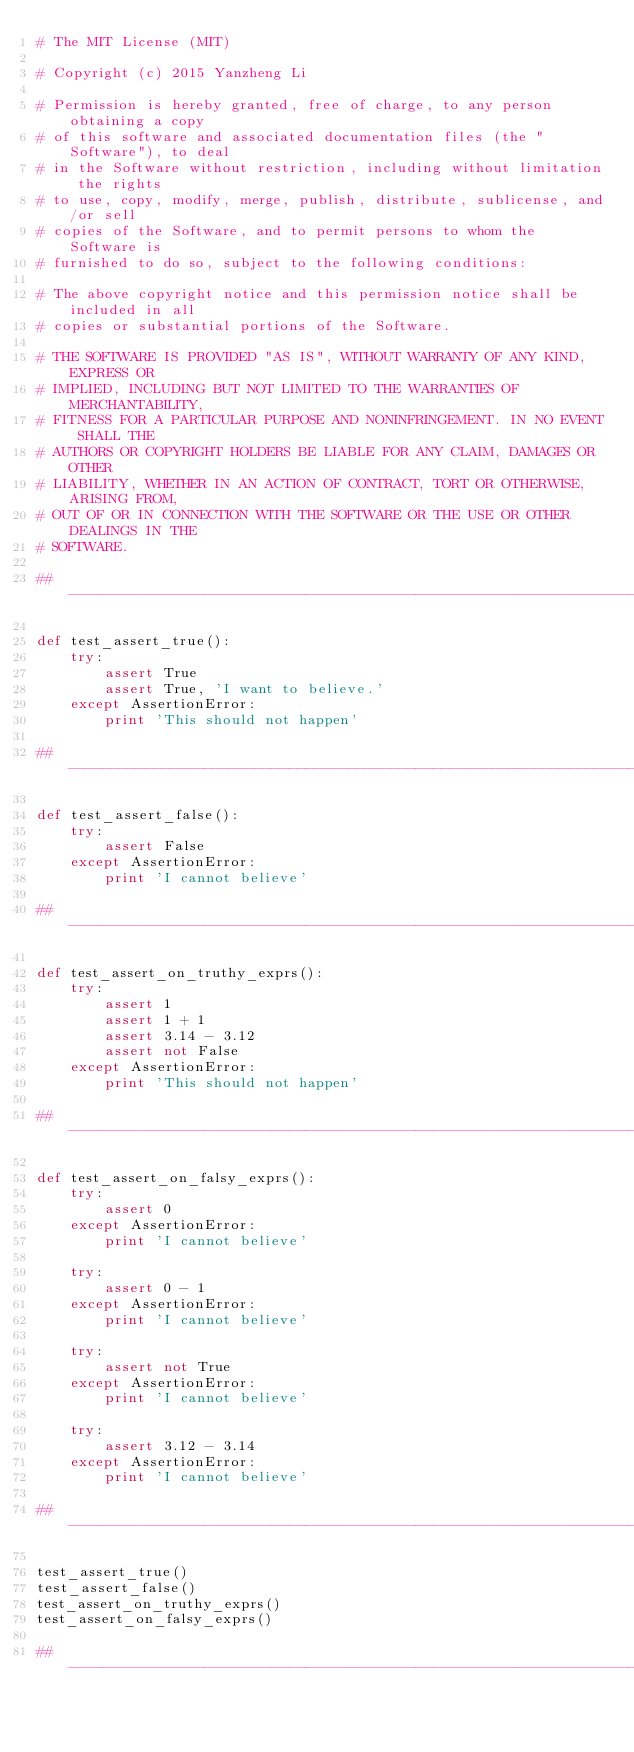Convert code to text. <code><loc_0><loc_0><loc_500><loc_500><_Python_># The MIT License (MIT)

# Copyright (c) 2015 Yanzheng Li

# Permission is hereby granted, free of charge, to any person obtaining a copy
# of this software and associated documentation files (the "Software"), to deal
# in the Software without restriction, including without limitation the rights
# to use, copy, modify, merge, publish, distribute, sublicense, and/or sell
# copies of the Software, and to permit persons to whom the Software is
# furnished to do so, subject to the following conditions:

# The above copyright notice and this permission notice shall be included in all
# copies or substantial portions of the Software.

# THE SOFTWARE IS PROVIDED "AS IS", WITHOUT WARRANTY OF ANY KIND, EXPRESS OR
# IMPLIED, INCLUDING BUT NOT LIMITED TO THE WARRANTIES OF MERCHANTABILITY,
# FITNESS FOR A PARTICULAR PURPOSE AND NONINFRINGEMENT. IN NO EVENT SHALL THE
# AUTHORS OR COPYRIGHT HOLDERS BE LIABLE FOR ANY CLAIM, DAMAGES OR OTHER
# LIABILITY, WHETHER IN AN ACTION OF CONTRACT, TORT OR OTHERWISE, ARISING FROM,
# OUT OF OR IN CONNECTION WITH THE SOFTWARE OR THE USE OR OTHER DEALINGS IN THE
# SOFTWARE.

## -----------------------------------------------------------------------------

def test_assert_true():
    try:
        assert True
        assert True, 'I want to believe.'
    except AssertionError:
        print 'This should not happen'

## -----------------------------------------------------------------------------

def test_assert_false():
    try:
        assert False
    except AssertionError:
        print 'I cannot believe'

## -----------------------------------------------------------------------------

def test_assert_on_truthy_exprs():
    try:
        assert 1
        assert 1 + 1
        assert 3.14 - 3.12
        assert not False
    except AssertionError:
        print 'This should not happen'

## -----------------------------------------------------------------------------

def test_assert_on_falsy_exprs():
    try:
        assert 0
    except AssertionError:
        print 'I cannot believe'

    try:
        assert 0 - 1
    except AssertionError:
        print 'I cannot believe'

    try:
        assert not True
    except AssertionError:
        print 'I cannot believe'

    try:
        assert 3.12 - 3.14
    except AssertionError:
        print 'I cannot believe'

## -----------------------------------------------------------------------------

test_assert_true()
test_assert_false()
test_assert_on_truthy_exprs()
test_assert_on_falsy_exprs()

## -----------------------------------------------------------------------------
</code> 